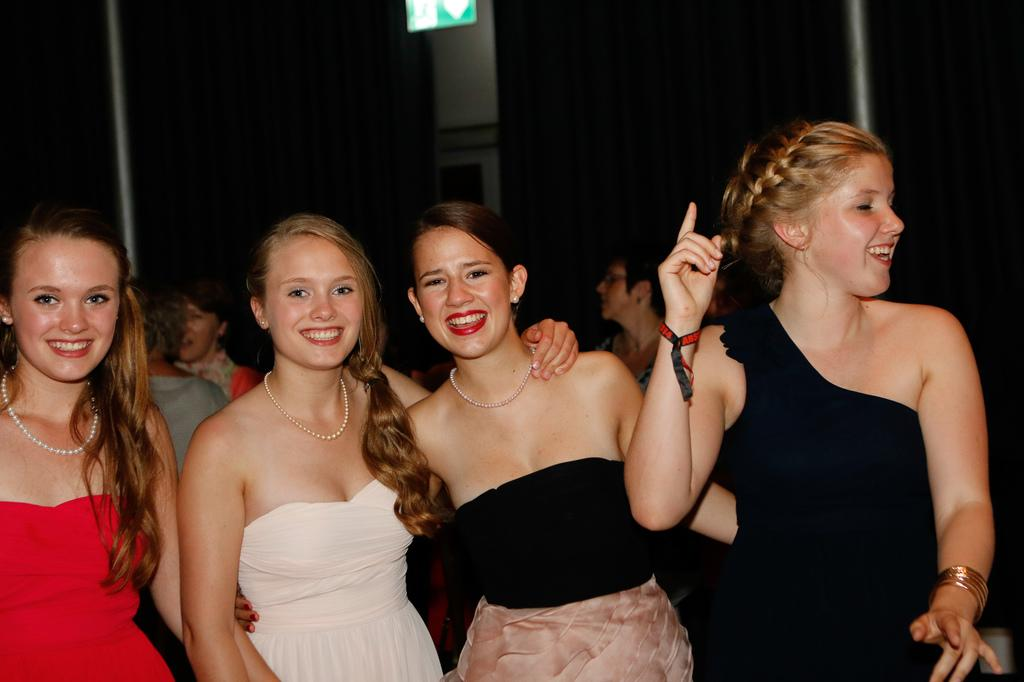What is the main subject of the image? The main subject of the image is girls standing. What is the emotional expression of the people in the image? The people in the image are smiling. What can be observed about the background of the image? The background of the image is dark. What type of substance is being used as bait in the image? There is no substance or bait present in the image; it features girls standing and smiling. 